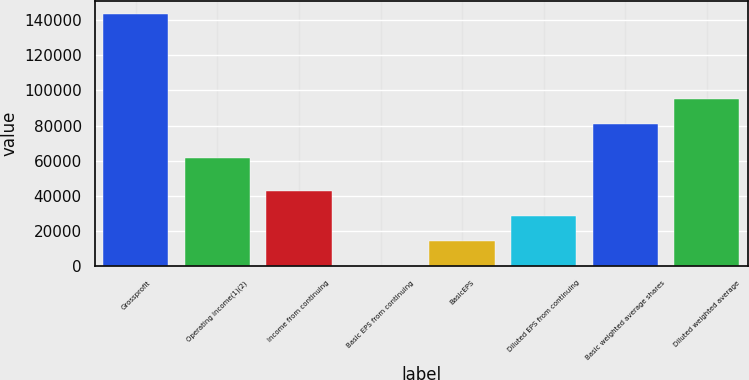Convert chart. <chart><loc_0><loc_0><loc_500><loc_500><bar_chart><fcel>Grossprofit<fcel>Operating income(1)(2)<fcel>Income from continuing<fcel>Basic EPS from continuing<fcel>BasicEPS<fcel>Diluted EPS from continuing<fcel>Basic weighted average shares<fcel>Diluted weighted average<nl><fcel>143586<fcel>61518<fcel>43076.1<fcel>0.47<fcel>14359<fcel>28717.6<fcel>80975<fcel>95333.6<nl></chart> 